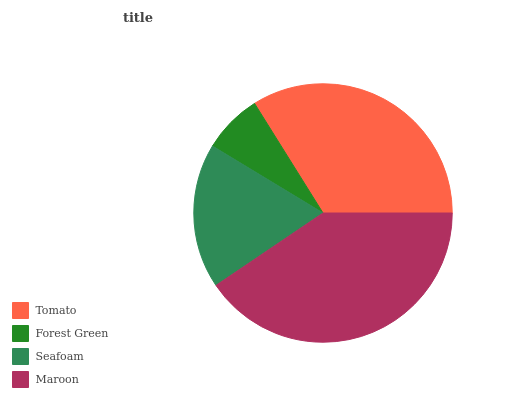Is Forest Green the minimum?
Answer yes or no. Yes. Is Maroon the maximum?
Answer yes or no. Yes. Is Seafoam the minimum?
Answer yes or no. No. Is Seafoam the maximum?
Answer yes or no. No. Is Seafoam greater than Forest Green?
Answer yes or no. Yes. Is Forest Green less than Seafoam?
Answer yes or no. Yes. Is Forest Green greater than Seafoam?
Answer yes or no. No. Is Seafoam less than Forest Green?
Answer yes or no. No. Is Tomato the high median?
Answer yes or no. Yes. Is Seafoam the low median?
Answer yes or no. Yes. Is Forest Green the high median?
Answer yes or no. No. Is Tomato the low median?
Answer yes or no. No. 